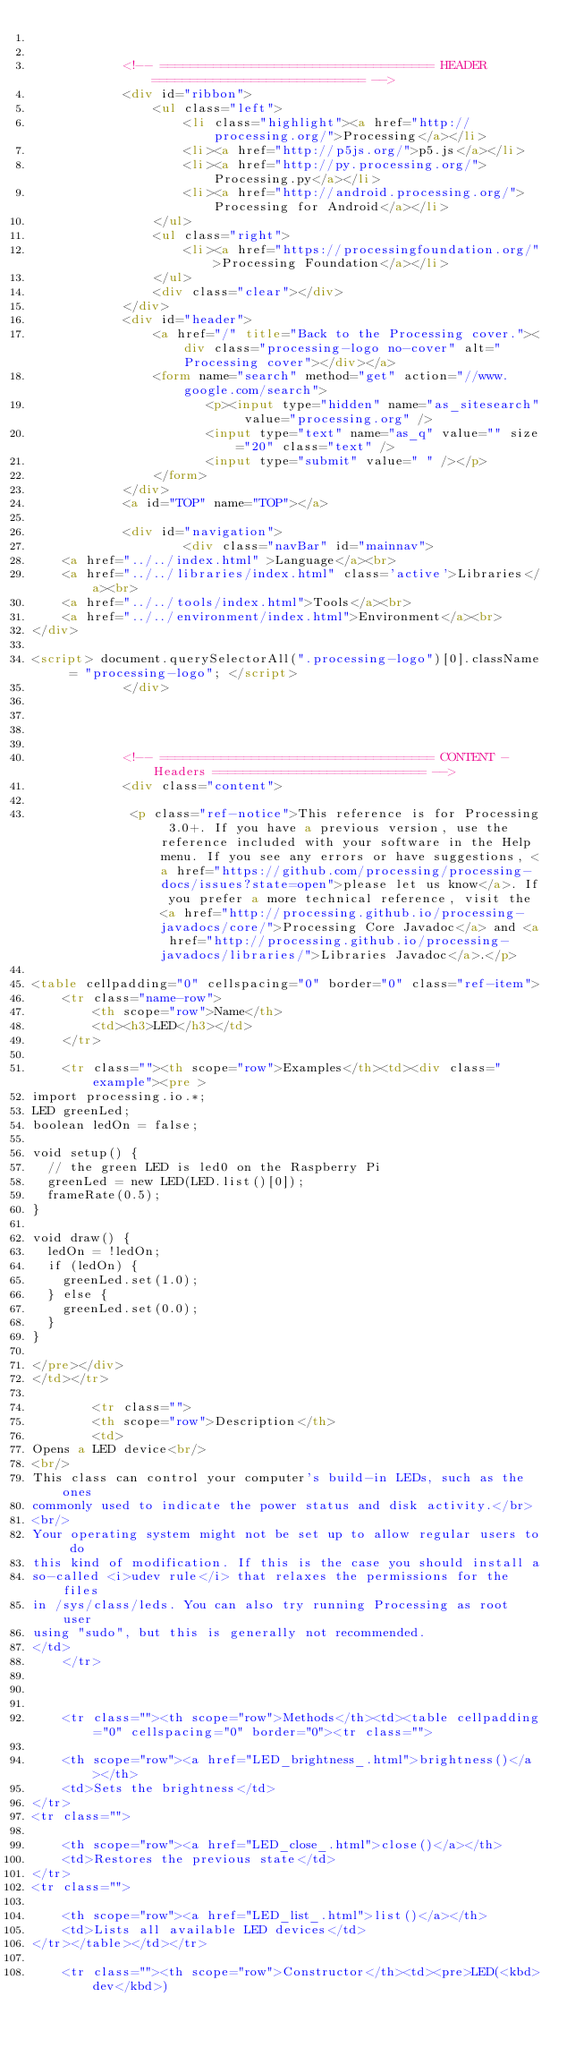<code> <loc_0><loc_0><loc_500><loc_500><_HTML_>

			<!-- ==================================== HEADER ============================ -->
			<div id="ribbon">
				<ul class="left">
					<li class="highlight"><a href="http://processing.org/">Processing</a></li>
					<li><a href="http://p5js.org/">p5.js</a></li>
					<li><a href="http://py.processing.org/">Processing.py</a></li>
					<li><a href="http://android.processing.org/">Processing for Android</a></li>
				</ul>
				<ul class="right">
					<li><a href="https://processingfoundation.org/">Processing Foundation</a></li>
				</ul>
				<div class="clear"></div>
			</div>
			<div id="header">
				<a href="/" title="Back to the Processing cover."><div class="processing-logo no-cover" alt="Processing cover"></div></a>
				<form name="search" method="get" action="//www.google.com/search">
				       <p><input type="hidden" name="as_sitesearch" value="processing.org" />
				       <input type="text" name="as_q" value="" size="20" class="text" />
				       <input type="submit" value=" " /></p>
				</form>
			</div>
			<a id="TOP" name="TOP"></a>

			<div id="navigation">
					<div class="navBar" id="mainnav">
	<a href="../../index.html" >Language</a><br>
	<a href="../../libraries/index.html" class='active'>Libraries</a><br>
	<a href="../../tools/index.html">Tools</a><br>
	<a href="../../environment/index.html">Environment</a><br>
</div>

<script> document.querySelectorAll(".processing-logo")[0].className = "processing-logo"; </script>
			</div>




			<!-- ==================================== CONTENT - Headers ============================ -->
			<div class="content">

			 <p class="ref-notice">This reference is for Processing 3.0+. If you have a previous version, use the reference included with your software in the Help menu. If you see any errors or have suggestions, <a href="https://github.com/processing/processing-docs/issues?state=open">please let us know</a>. If you prefer a more technical reference, visit the <a href="http://processing.github.io/processing-javadocs/core/">Processing Core Javadoc</a> and <a href="http://processing.github.io/processing-javadocs/libraries/">Libraries Javadoc</a>.</p>

<table cellpadding="0" cellspacing="0" border="0" class="ref-item">
	<tr class="name-row">
		<th scope="row">Name</th>
		<td><h3>LED</h3></td>
	</tr>

	<tr class=""><th scope="row">Examples</th><td><div class="example"><pre >
import processing.io.*;
LED greenLed;
boolean ledOn = false;

void setup() {
  // the green LED is led0 on the Raspberry Pi
  greenLed = new LED(LED.list()[0]);
  frameRate(0.5);
}

void draw() {
  ledOn = !ledOn;
  if (ledOn) {
  	greenLed.set(1.0);
  } else {
  	greenLed.set(0.0);
  }
}

</pre></div>
</td></tr>

		<tr class="">
		<th scope="row">Description</th>
		<td>
Opens a LED device<br/>
<br/>
This class can control your computer's build-in LEDs, such as the ones
commonly used to indicate the power status and disk activity.</br>
<br/>
Your operating system might not be set up to allow regular users to do
this kind of modification. If this is the case you should install a
so-called <i>udev rule</i> that relaxes the permissions for the files
in /sys/class/leds. You can also try running Processing as root user
using "sudo", but this is generally not recommended.
</td>
	</tr>



	<tr class=""><th scope="row">Methods</th><td><table cellpadding="0" cellspacing="0" border="0"><tr class="">

	<th scope="row"><a href="LED_brightness_.html">brightness()</a></th>
	<td>Sets the brightness</td>
</tr>
<tr class="">

	<th scope="row"><a href="LED_close_.html">close()</a></th>
	<td>Restores the previous state</td>
</tr>
<tr class="">

	<th scope="row"><a href="LED_list_.html">list()</a></th>
	<td>Lists all available LED devices</td>
</tr></table></td></tr>

	<tr class=""><th scope="row">Constructor</th><td><pre>LED(<kbd>dev</kbd>)</code> 